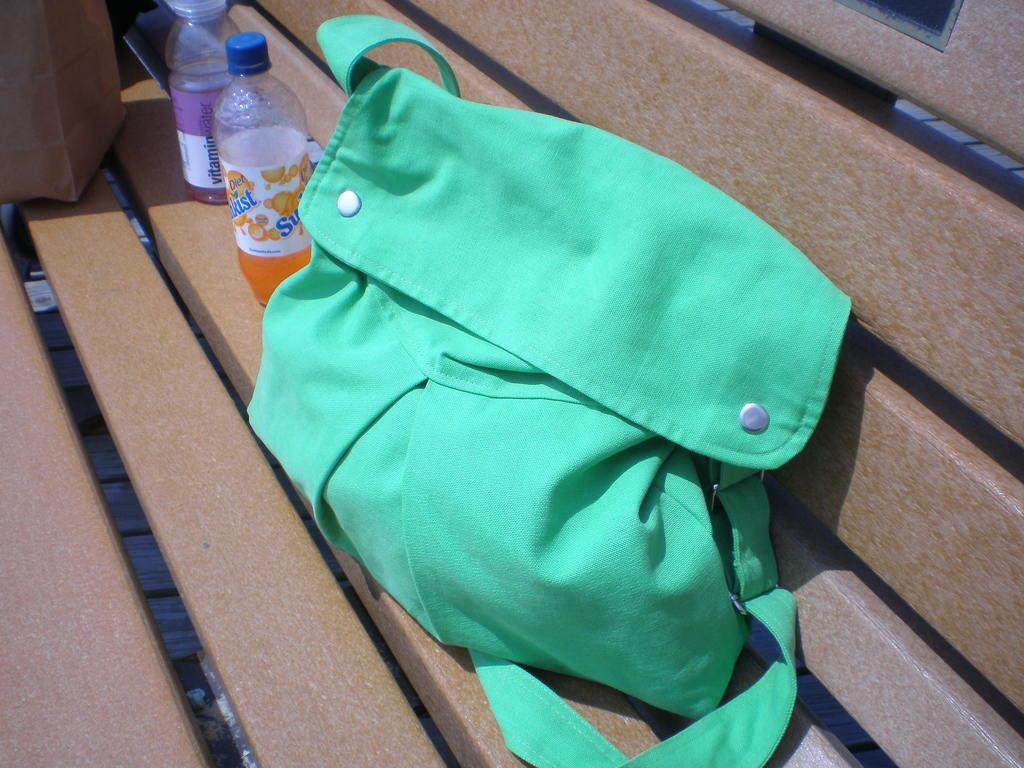What color is the bag in the image? The bag in the image is green. What feature is attached to the bag? The bag has a belt attached to it. What type of items can be seen in the image besides the bag? There are bottles with drinks and a box in the image. Where are the items placed in the image? The items are placed on a bench. What type of plant is growing out of the box in the image? There is no plant growing out of the box in the image; it is a box with other items placed on it. 